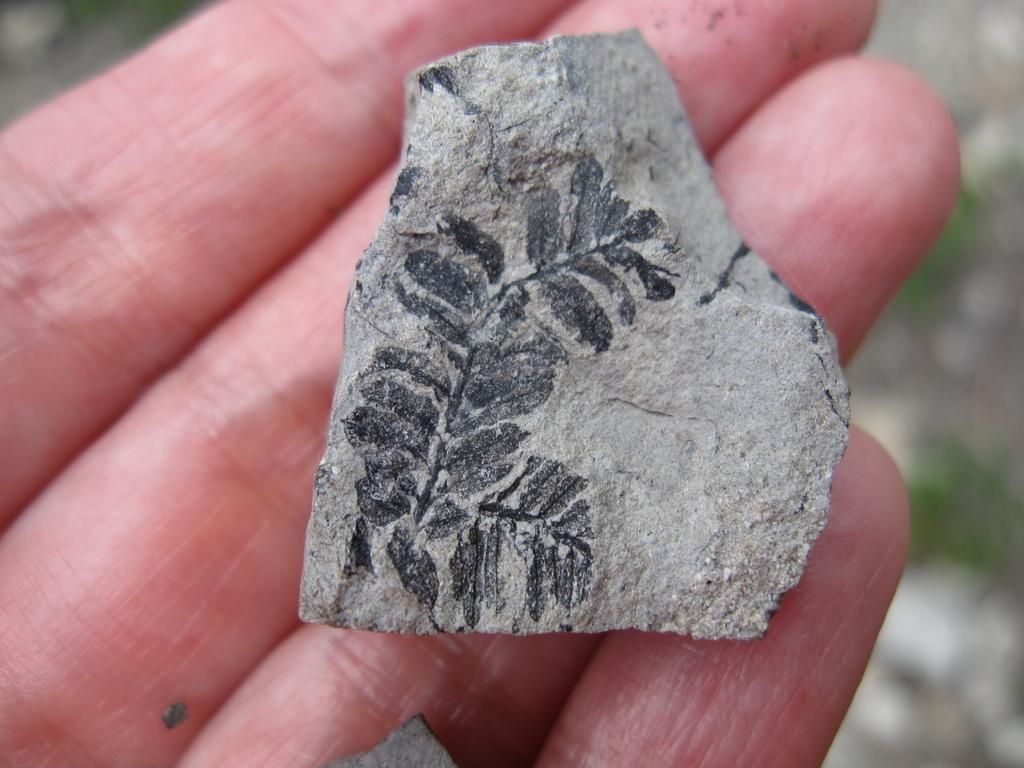What object is in the image? There is a stone in the image. Where is the stone located? The stone is placed in a hand. What type of corn is being used as a mask in the image? There is no corn or mask present in the image; it only features a stone placed in a hand. 